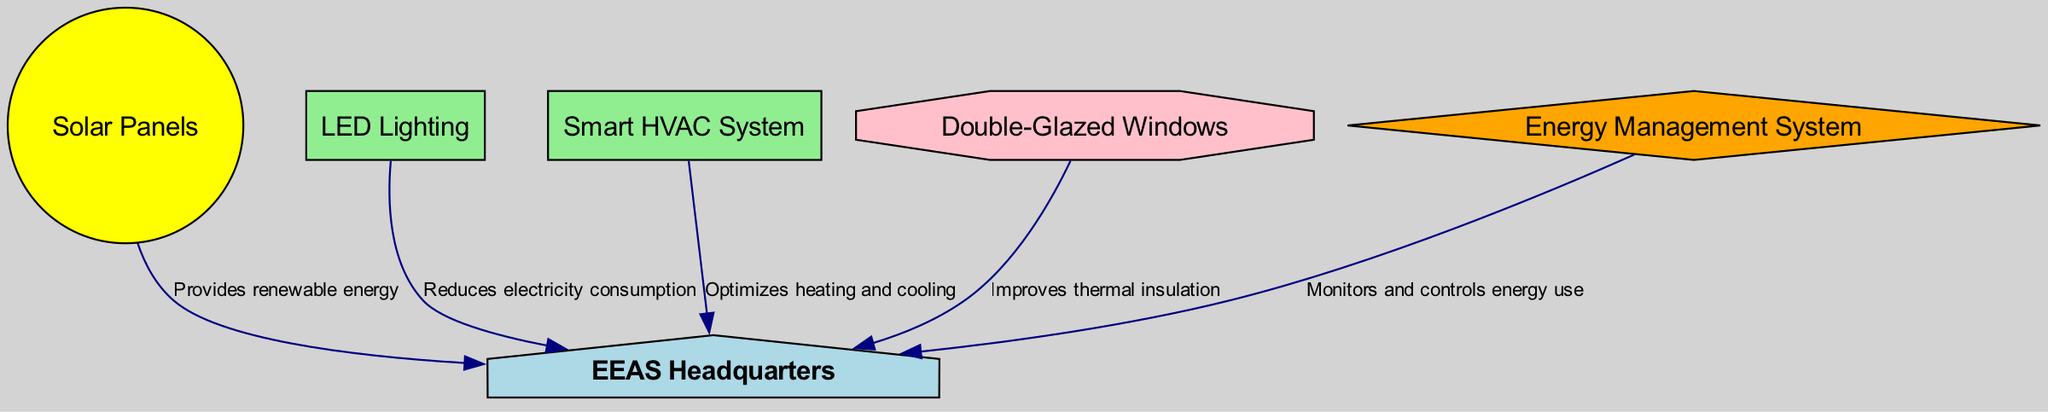What is the main building depicted in the diagram? The diagram features the "EEAS Headquarters" as the primary building indicated by its label.
Answer: EEAS Headquarters How many efficiency upgrades are included in the diagram? There are three efficiency upgrades listed in the diagram: LED Lighting, Smart HVAC System, and Double-Glazed Windows. Counting these provides the total.
Answer: 3 What energy source is connected to the EEAS Headquarters? The diagram shows "Solar Panels" as the energy source providing renewable energy directly to the EEAS Headquarters.
Answer: Solar Panels Which upgrade reduces electricity consumption? The LED Lighting is specifically indicated to reduce electricity consumption in its label.
Answer: LED Lighting What aspect does the Energy Management System monitor? The Energy Management System in the diagram is responsible for monitoring and controlling energy use for the EEAS Headquarters, as shown in its connection.
Answer: Energy use Which type of upgrade optimizes heating and cooling? The "Smart HVAC System" is labeled in the diagram as the upgrade that optimizes heating and cooling for the EEAS Headquarters.
Answer: Smart HVAC System How does the Double-Glazed Windows improve performance? The Double-Glazed Windows are indicated in the diagram to improve thermal insulation, as shown by its connecting label.
Answer: Improves thermal insulation What color represents the Efficiency Upgrade nodes? The diagram uses a light green fill color for the nodes categorized as Efficiency Upgrades, which includes both LED Lighting and Smart HVAC System.
Answer: Light green How many total connections (edges) are made in the diagram? By counting all the directed edges in the diagram, we can see there are five edges connecting various nodes to the EEAS Headquarters.
Answer: 5 